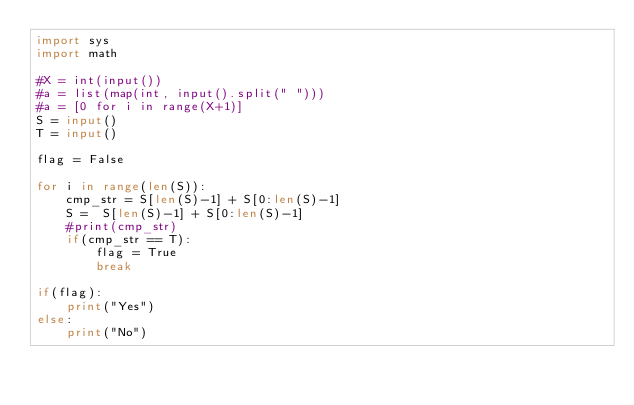<code> <loc_0><loc_0><loc_500><loc_500><_Python_>import sys 
import math

#X = int(input())
#a = list(map(int, input().split(" ")))
#a = [0 for i in range(X+1)]
S = input()
T = input()

flag = False

for i in range(len(S)):
    cmp_str = S[len(S)-1] + S[0:len(S)-1]
    S =  S[len(S)-1] + S[0:len(S)-1]
    #print(cmp_str)
    if(cmp_str == T):
        flag = True
        break

if(flag):
    print("Yes")
else:
    print("No")</code> 